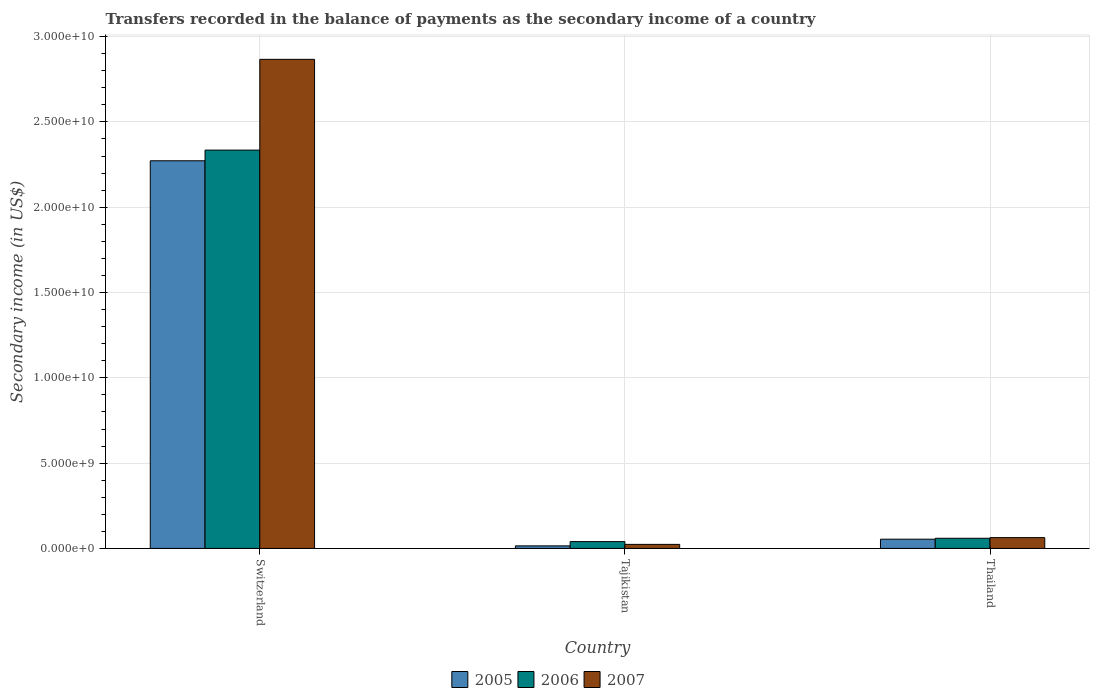How many groups of bars are there?
Your answer should be compact. 3. Are the number of bars per tick equal to the number of legend labels?
Your answer should be very brief. Yes. How many bars are there on the 3rd tick from the left?
Your answer should be compact. 3. How many bars are there on the 3rd tick from the right?
Offer a very short reply. 3. What is the label of the 3rd group of bars from the left?
Keep it short and to the point. Thailand. In how many cases, is the number of bars for a given country not equal to the number of legend labels?
Your response must be concise. 0. What is the secondary income of in 2005 in Thailand?
Ensure brevity in your answer.  5.41e+08. Across all countries, what is the maximum secondary income of in 2007?
Offer a very short reply. 2.87e+1. Across all countries, what is the minimum secondary income of in 2005?
Keep it short and to the point. 1.50e+08. In which country was the secondary income of in 2006 maximum?
Offer a terse response. Switzerland. In which country was the secondary income of in 2005 minimum?
Give a very brief answer. Tajikistan. What is the total secondary income of in 2006 in the graph?
Give a very brief answer. 2.43e+1. What is the difference between the secondary income of in 2006 in Tajikistan and that in Thailand?
Provide a short and direct response. -1.96e+08. What is the difference between the secondary income of in 2005 in Thailand and the secondary income of in 2007 in Switzerland?
Offer a terse response. -2.81e+1. What is the average secondary income of in 2007 per country?
Provide a short and direct response. 9.85e+09. What is the difference between the secondary income of of/in 2006 and secondary income of of/in 2007 in Tajikistan?
Your answer should be compact. 1.63e+08. What is the ratio of the secondary income of in 2005 in Switzerland to that in Thailand?
Your answer should be compact. 41.96. Is the difference between the secondary income of in 2006 in Tajikistan and Thailand greater than the difference between the secondary income of in 2007 in Tajikistan and Thailand?
Offer a terse response. Yes. What is the difference between the highest and the second highest secondary income of in 2007?
Your answer should be compact. -3.96e+08. What is the difference between the highest and the lowest secondary income of in 2005?
Your answer should be very brief. 2.26e+1. In how many countries, is the secondary income of in 2007 greater than the average secondary income of in 2007 taken over all countries?
Provide a succinct answer. 1. What is the difference between two consecutive major ticks on the Y-axis?
Provide a short and direct response. 5.00e+09. Are the values on the major ticks of Y-axis written in scientific E-notation?
Your answer should be compact. Yes. How many legend labels are there?
Your answer should be compact. 3. How are the legend labels stacked?
Provide a short and direct response. Horizontal. What is the title of the graph?
Make the answer very short. Transfers recorded in the balance of payments as the secondary income of a country. Does "1970" appear as one of the legend labels in the graph?
Provide a succinct answer. No. What is the label or title of the X-axis?
Your answer should be compact. Country. What is the label or title of the Y-axis?
Ensure brevity in your answer.  Secondary income (in US$). What is the Secondary income (in US$) of 2005 in Switzerland?
Your answer should be compact. 2.27e+1. What is the Secondary income (in US$) in 2006 in Switzerland?
Provide a short and direct response. 2.33e+1. What is the Secondary income (in US$) in 2007 in Switzerland?
Your response must be concise. 2.87e+1. What is the Secondary income (in US$) of 2005 in Tajikistan?
Offer a very short reply. 1.50e+08. What is the Secondary income (in US$) in 2006 in Tajikistan?
Offer a terse response. 4.00e+08. What is the Secondary income (in US$) in 2007 in Tajikistan?
Provide a short and direct response. 2.37e+08. What is the Secondary income (in US$) in 2005 in Thailand?
Ensure brevity in your answer.  5.41e+08. What is the Secondary income (in US$) of 2006 in Thailand?
Provide a short and direct response. 5.96e+08. What is the Secondary income (in US$) of 2007 in Thailand?
Keep it short and to the point. 6.33e+08. Across all countries, what is the maximum Secondary income (in US$) of 2005?
Your answer should be compact. 2.27e+1. Across all countries, what is the maximum Secondary income (in US$) in 2006?
Your answer should be compact. 2.33e+1. Across all countries, what is the maximum Secondary income (in US$) of 2007?
Give a very brief answer. 2.87e+1. Across all countries, what is the minimum Secondary income (in US$) of 2005?
Keep it short and to the point. 1.50e+08. Across all countries, what is the minimum Secondary income (in US$) in 2006?
Ensure brevity in your answer.  4.00e+08. Across all countries, what is the minimum Secondary income (in US$) of 2007?
Provide a short and direct response. 2.37e+08. What is the total Secondary income (in US$) in 2005 in the graph?
Offer a terse response. 2.34e+1. What is the total Secondary income (in US$) in 2006 in the graph?
Your answer should be very brief. 2.43e+1. What is the total Secondary income (in US$) in 2007 in the graph?
Offer a very short reply. 2.95e+1. What is the difference between the Secondary income (in US$) in 2005 in Switzerland and that in Tajikistan?
Give a very brief answer. 2.26e+1. What is the difference between the Secondary income (in US$) of 2006 in Switzerland and that in Tajikistan?
Offer a terse response. 2.29e+1. What is the difference between the Secondary income (in US$) of 2007 in Switzerland and that in Tajikistan?
Provide a short and direct response. 2.84e+1. What is the difference between the Secondary income (in US$) of 2005 in Switzerland and that in Thailand?
Offer a very short reply. 2.22e+1. What is the difference between the Secondary income (in US$) in 2006 in Switzerland and that in Thailand?
Keep it short and to the point. 2.28e+1. What is the difference between the Secondary income (in US$) in 2007 in Switzerland and that in Thailand?
Offer a terse response. 2.80e+1. What is the difference between the Secondary income (in US$) of 2005 in Tajikistan and that in Thailand?
Give a very brief answer. -3.91e+08. What is the difference between the Secondary income (in US$) of 2006 in Tajikistan and that in Thailand?
Your answer should be very brief. -1.96e+08. What is the difference between the Secondary income (in US$) in 2007 in Tajikistan and that in Thailand?
Your response must be concise. -3.96e+08. What is the difference between the Secondary income (in US$) of 2005 in Switzerland and the Secondary income (in US$) of 2006 in Tajikistan?
Your response must be concise. 2.23e+1. What is the difference between the Secondary income (in US$) of 2005 in Switzerland and the Secondary income (in US$) of 2007 in Tajikistan?
Offer a terse response. 2.25e+1. What is the difference between the Secondary income (in US$) in 2006 in Switzerland and the Secondary income (in US$) in 2007 in Tajikistan?
Provide a short and direct response. 2.31e+1. What is the difference between the Secondary income (in US$) of 2005 in Switzerland and the Secondary income (in US$) of 2006 in Thailand?
Ensure brevity in your answer.  2.21e+1. What is the difference between the Secondary income (in US$) in 2005 in Switzerland and the Secondary income (in US$) in 2007 in Thailand?
Your answer should be very brief. 2.21e+1. What is the difference between the Secondary income (in US$) of 2006 in Switzerland and the Secondary income (in US$) of 2007 in Thailand?
Provide a succinct answer. 2.27e+1. What is the difference between the Secondary income (in US$) in 2005 in Tajikistan and the Secondary income (in US$) in 2006 in Thailand?
Provide a succinct answer. -4.46e+08. What is the difference between the Secondary income (in US$) in 2005 in Tajikistan and the Secondary income (in US$) in 2007 in Thailand?
Offer a very short reply. -4.83e+08. What is the difference between the Secondary income (in US$) in 2006 in Tajikistan and the Secondary income (in US$) in 2007 in Thailand?
Offer a very short reply. -2.33e+08. What is the average Secondary income (in US$) of 2005 per country?
Ensure brevity in your answer.  7.80e+09. What is the average Secondary income (in US$) of 2006 per country?
Your answer should be compact. 8.11e+09. What is the average Secondary income (in US$) in 2007 per country?
Provide a short and direct response. 9.85e+09. What is the difference between the Secondary income (in US$) in 2005 and Secondary income (in US$) in 2006 in Switzerland?
Offer a terse response. -6.26e+08. What is the difference between the Secondary income (in US$) in 2005 and Secondary income (in US$) in 2007 in Switzerland?
Keep it short and to the point. -5.95e+09. What is the difference between the Secondary income (in US$) of 2006 and Secondary income (in US$) of 2007 in Switzerland?
Provide a short and direct response. -5.32e+09. What is the difference between the Secondary income (in US$) in 2005 and Secondary income (in US$) in 2006 in Tajikistan?
Provide a succinct answer. -2.50e+08. What is the difference between the Secondary income (in US$) of 2005 and Secondary income (in US$) of 2007 in Tajikistan?
Your answer should be compact. -8.72e+07. What is the difference between the Secondary income (in US$) in 2006 and Secondary income (in US$) in 2007 in Tajikistan?
Keep it short and to the point. 1.63e+08. What is the difference between the Secondary income (in US$) of 2005 and Secondary income (in US$) of 2006 in Thailand?
Offer a terse response. -5.44e+07. What is the difference between the Secondary income (in US$) in 2005 and Secondary income (in US$) in 2007 in Thailand?
Ensure brevity in your answer.  -9.15e+07. What is the difference between the Secondary income (in US$) of 2006 and Secondary income (in US$) of 2007 in Thailand?
Your answer should be very brief. -3.71e+07. What is the ratio of the Secondary income (in US$) in 2005 in Switzerland to that in Tajikistan?
Give a very brief answer. 151.49. What is the ratio of the Secondary income (in US$) of 2006 in Switzerland to that in Tajikistan?
Offer a very short reply. 58.31. What is the ratio of the Secondary income (in US$) in 2007 in Switzerland to that in Tajikistan?
Give a very brief answer. 120.89. What is the ratio of the Secondary income (in US$) of 2005 in Switzerland to that in Thailand?
Your answer should be very brief. 41.96. What is the ratio of the Secondary income (in US$) of 2006 in Switzerland to that in Thailand?
Keep it short and to the point. 39.18. What is the ratio of the Secondary income (in US$) of 2007 in Switzerland to that in Thailand?
Your response must be concise. 45.29. What is the ratio of the Secondary income (in US$) of 2005 in Tajikistan to that in Thailand?
Keep it short and to the point. 0.28. What is the ratio of the Secondary income (in US$) of 2006 in Tajikistan to that in Thailand?
Give a very brief answer. 0.67. What is the ratio of the Secondary income (in US$) of 2007 in Tajikistan to that in Thailand?
Your response must be concise. 0.37. What is the difference between the highest and the second highest Secondary income (in US$) of 2005?
Your answer should be very brief. 2.22e+1. What is the difference between the highest and the second highest Secondary income (in US$) in 2006?
Keep it short and to the point. 2.28e+1. What is the difference between the highest and the second highest Secondary income (in US$) in 2007?
Offer a very short reply. 2.80e+1. What is the difference between the highest and the lowest Secondary income (in US$) of 2005?
Make the answer very short. 2.26e+1. What is the difference between the highest and the lowest Secondary income (in US$) of 2006?
Offer a very short reply. 2.29e+1. What is the difference between the highest and the lowest Secondary income (in US$) in 2007?
Offer a very short reply. 2.84e+1. 